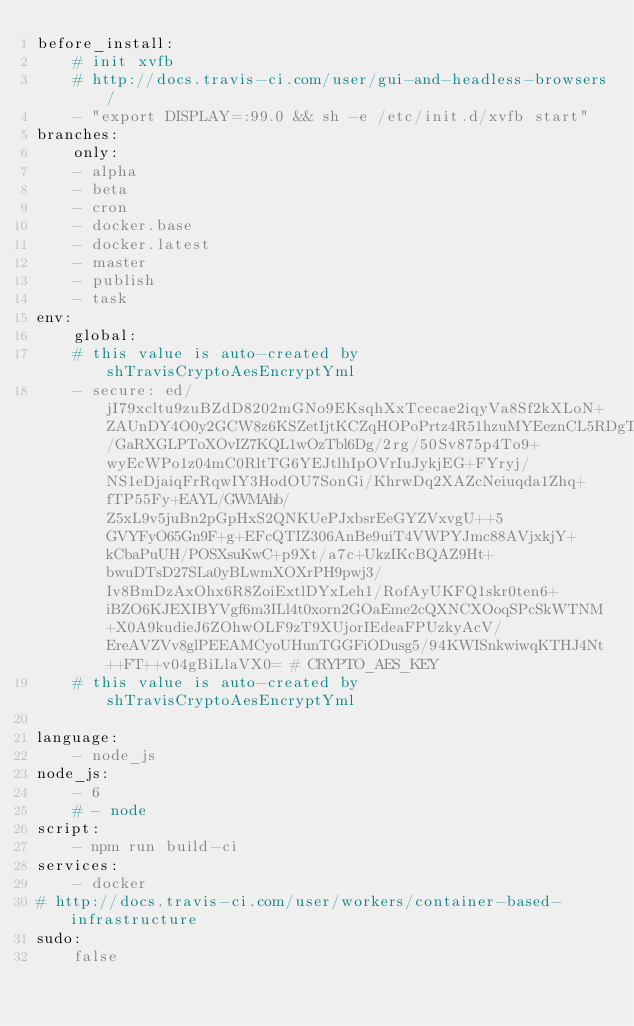Convert code to text. <code><loc_0><loc_0><loc_500><loc_500><_YAML_>before_install:
    # init xvfb
    # http://docs.travis-ci.com/user/gui-and-headless-browsers/
    - "export DISPLAY=:99.0 && sh -e /etc/init.d/xvfb start"
branches:
    only:
    - alpha
    - beta
    - cron
    - docker.base
    - docker.latest
    - master
    - publish
    - task
env:
    global:
    # this value is auto-created by shTravisCryptoAesEncryptYml
    - secure: ed/jI79xcltu9zuBZdD8202mGNo9EKsqhXxTcecae2iqyVa8Sf2kXLoN+ZAUnDY4O0y2GCW8z6KSZetIjtKCZqHOPoPrtz4R51hzuMYEeznCL5RDgTKePKo44oXK2X9okDzevt/GaRXGLPToXOvIZ7KQL1wOzTbl6Dg/2rg/50Sv875p4To9+wyEcWPo1z04mC0RltTG6YEJtlhIpOVrIuJykjEG+FYryj/NS1eDjaiqFrRqwIY3HodOU7SonGi/KhrwDq2XAZcNeiuqda1Zhq+fTP55Fy+EAYL/GWMAhb/Z5xL9v5juBn2pGpHxS2QNKUePJxbsrEeGYZVxvgU++5GVYFyO65Gn9F+g+EFcQTIZ306AnBe9uiT4VWPYJmc88AVjxkjY+kCbaPuUH/POSXsuKwC+p9Xt/a7c+UkzIKcBQAZ9Ht+bwuDTsD27SLa0yBLwmXOXrPH9pwj3/Iv8BmDzAxOhx6R8ZoiExtlDYxLeh1/RofAyUKFQ1skr0ten6+iBZO6KJEXIBYVgf6m3ILl4t0xorn2GOaEme2cQXNCXOoqSPcSkWTNM+X0A9kudieJ6ZOhwOLF9zT9XUjorIEdeaFPUzkyAcV/EreAVZVv8glPEEAMCyoUHunTGGFiODusg5/94KWISnkwiwqKTHJ4Nt++FT++v04gBiLlaVX0= # CRYPTO_AES_KEY
    # this value is auto-created by shTravisCryptoAesEncryptYml

language:
    - node_js
node_js:
    - 6
    # - node
script:
    - npm run build-ci
services:
    - docker
# http://docs.travis-ci.com/user/workers/container-based-infrastructure
sudo:
    false
</code> 